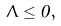<formula> <loc_0><loc_0><loc_500><loc_500>\Lambda \leq 0 ,</formula> 